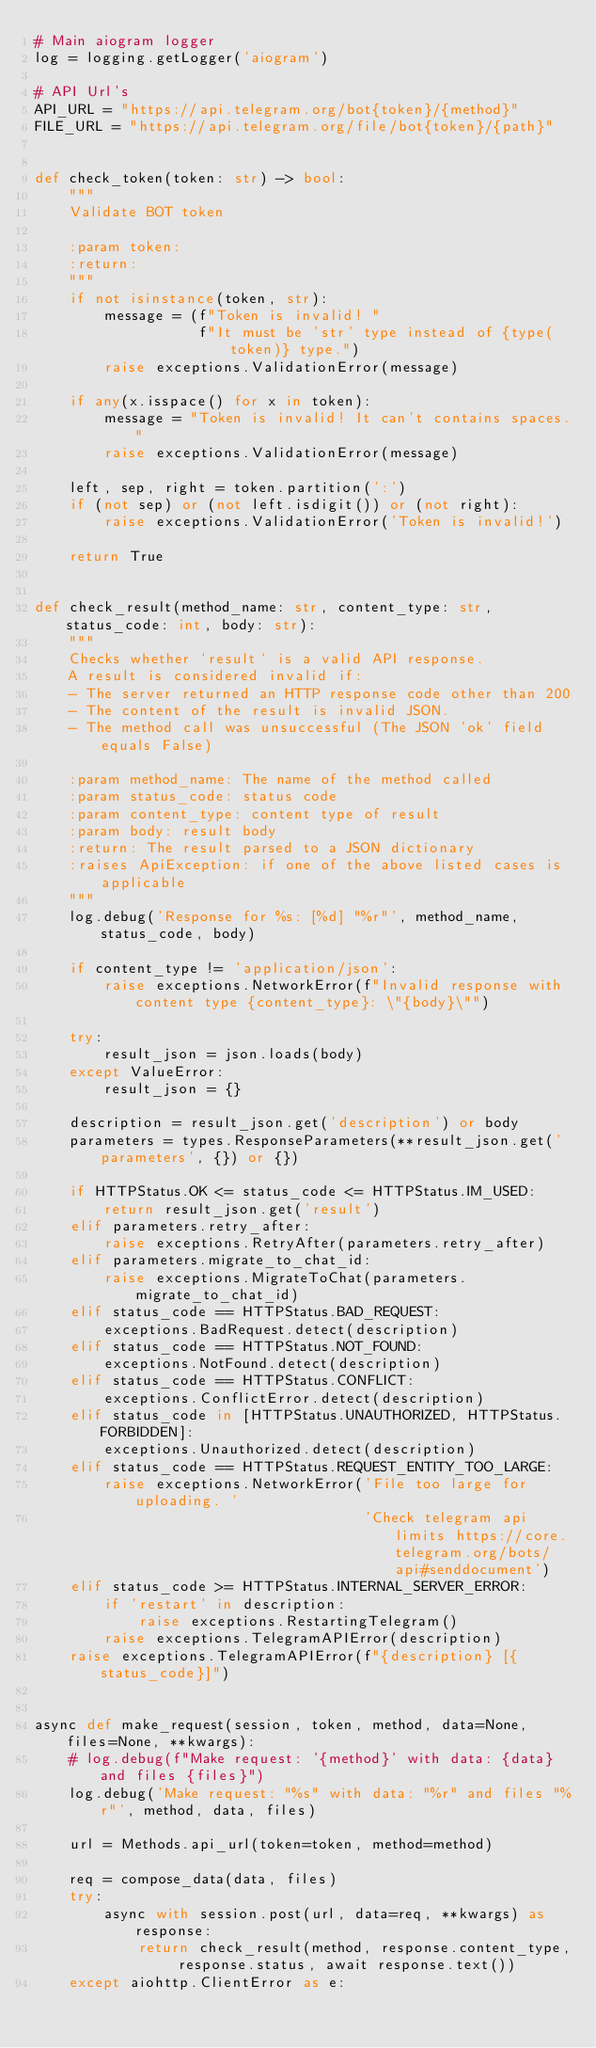<code> <loc_0><loc_0><loc_500><loc_500><_Python_># Main aiogram logger
log = logging.getLogger('aiogram')

# API Url's
API_URL = "https://api.telegram.org/bot{token}/{method}"
FILE_URL = "https://api.telegram.org/file/bot{token}/{path}"


def check_token(token: str) -> bool:
    """
    Validate BOT token

    :param token:
    :return:
    """
    if not isinstance(token, str):
        message = (f"Token is invalid! "
                   f"It must be 'str' type instead of {type(token)} type.")
        raise exceptions.ValidationError(message)

    if any(x.isspace() for x in token):
        message = "Token is invalid! It can't contains spaces."
        raise exceptions.ValidationError(message)

    left, sep, right = token.partition(':')
    if (not sep) or (not left.isdigit()) or (not right):
        raise exceptions.ValidationError('Token is invalid!')

    return True


def check_result(method_name: str, content_type: str, status_code: int, body: str):
    """
    Checks whether `result` is a valid API response.
    A result is considered invalid if:
    - The server returned an HTTP response code other than 200
    - The content of the result is invalid JSON.
    - The method call was unsuccessful (The JSON 'ok' field equals False)

    :param method_name: The name of the method called
    :param status_code: status code
    :param content_type: content type of result
    :param body: result body
    :return: The result parsed to a JSON dictionary
    :raises ApiException: if one of the above listed cases is applicable
    """
    log.debug('Response for %s: [%d] "%r"', method_name, status_code, body)

    if content_type != 'application/json':
        raise exceptions.NetworkError(f"Invalid response with content type {content_type}: \"{body}\"")

    try:
        result_json = json.loads(body)
    except ValueError:
        result_json = {}

    description = result_json.get('description') or body
    parameters = types.ResponseParameters(**result_json.get('parameters', {}) or {})

    if HTTPStatus.OK <= status_code <= HTTPStatus.IM_USED:
        return result_json.get('result')
    elif parameters.retry_after:
        raise exceptions.RetryAfter(parameters.retry_after)
    elif parameters.migrate_to_chat_id:
        raise exceptions.MigrateToChat(parameters.migrate_to_chat_id)
    elif status_code == HTTPStatus.BAD_REQUEST:
        exceptions.BadRequest.detect(description)
    elif status_code == HTTPStatus.NOT_FOUND:
        exceptions.NotFound.detect(description)
    elif status_code == HTTPStatus.CONFLICT:
        exceptions.ConflictError.detect(description)
    elif status_code in [HTTPStatus.UNAUTHORIZED, HTTPStatus.FORBIDDEN]:
        exceptions.Unauthorized.detect(description)
    elif status_code == HTTPStatus.REQUEST_ENTITY_TOO_LARGE:
        raise exceptions.NetworkError('File too large for uploading. '
                                      'Check telegram api limits https://core.telegram.org/bots/api#senddocument')
    elif status_code >= HTTPStatus.INTERNAL_SERVER_ERROR:
        if 'restart' in description:
            raise exceptions.RestartingTelegram()
        raise exceptions.TelegramAPIError(description)
    raise exceptions.TelegramAPIError(f"{description} [{status_code}]")


async def make_request(session, token, method, data=None, files=None, **kwargs):
    # log.debug(f"Make request: '{method}' with data: {data} and files {files}")
    log.debug('Make request: "%s" with data: "%r" and files "%r"', method, data, files)

    url = Methods.api_url(token=token, method=method)

    req = compose_data(data, files)
    try:
        async with session.post(url, data=req, **kwargs) as response:
            return check_result(method, response.content_type, response.status, await response.text())
    except aiohttp.ClientError as e:</code> 